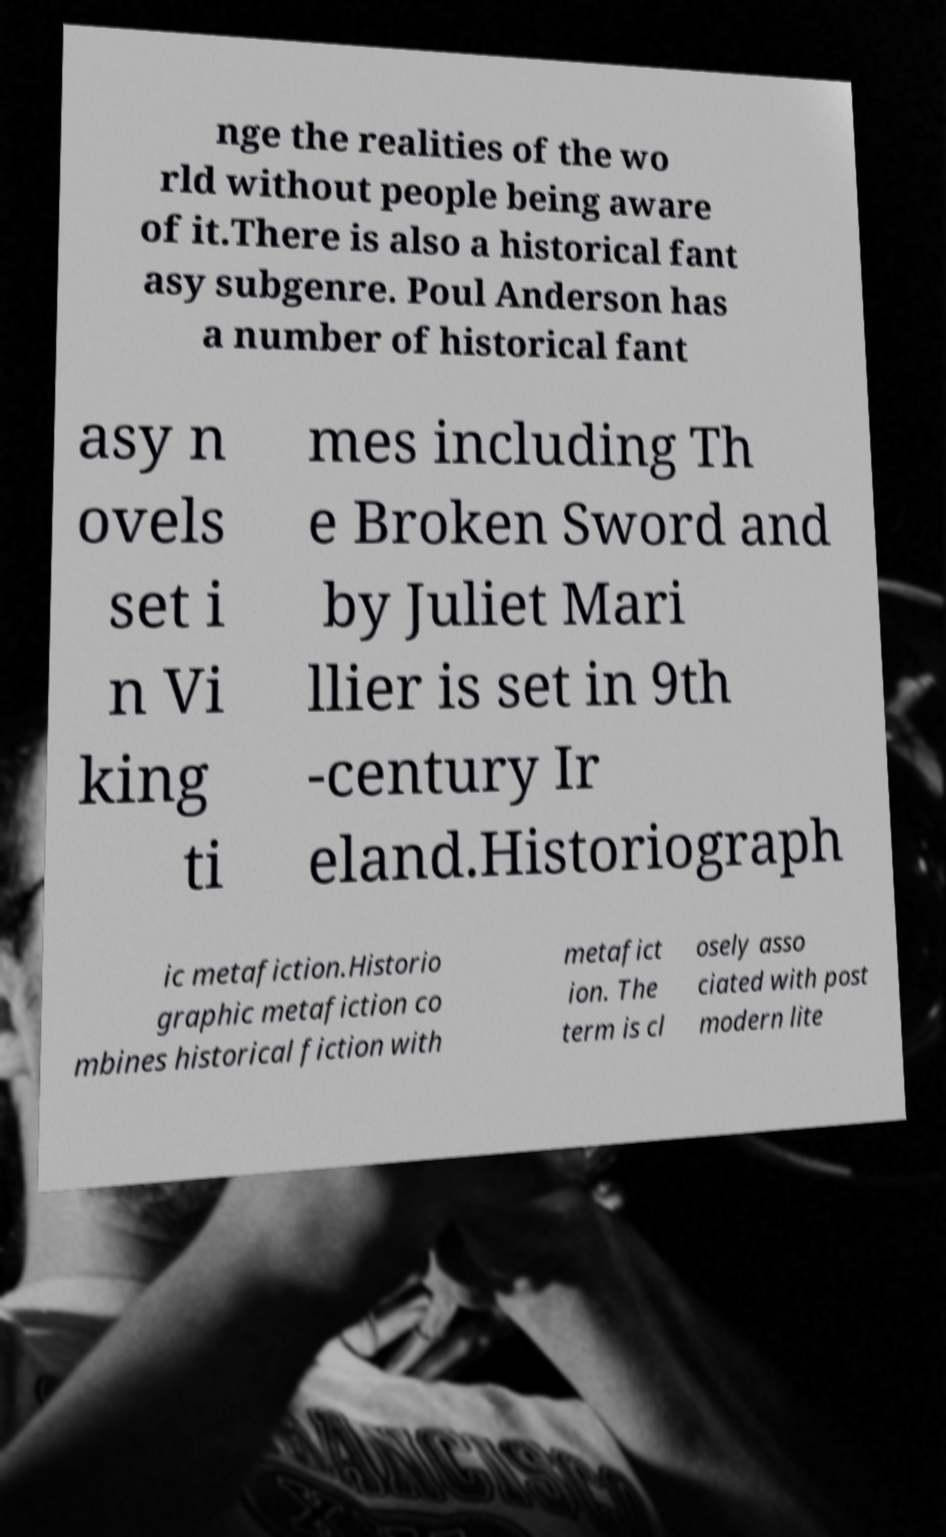Please identify and transcribe the text found in this image. nge the realities of the wo rld without people being aware of it.There is also a historical fant asy subgenre. Poul Anderson has a number of historical fant asy n ovels set i n Vi king ti mes including Th e Broken Sword and by Juliet Mari llier is set in 9th -century Ir eland.Historiograph ic metafiction.Historio graphic metafiction co mbines historical fiction with metafict ion. The term is cl osely asso ciated with post modern lite 